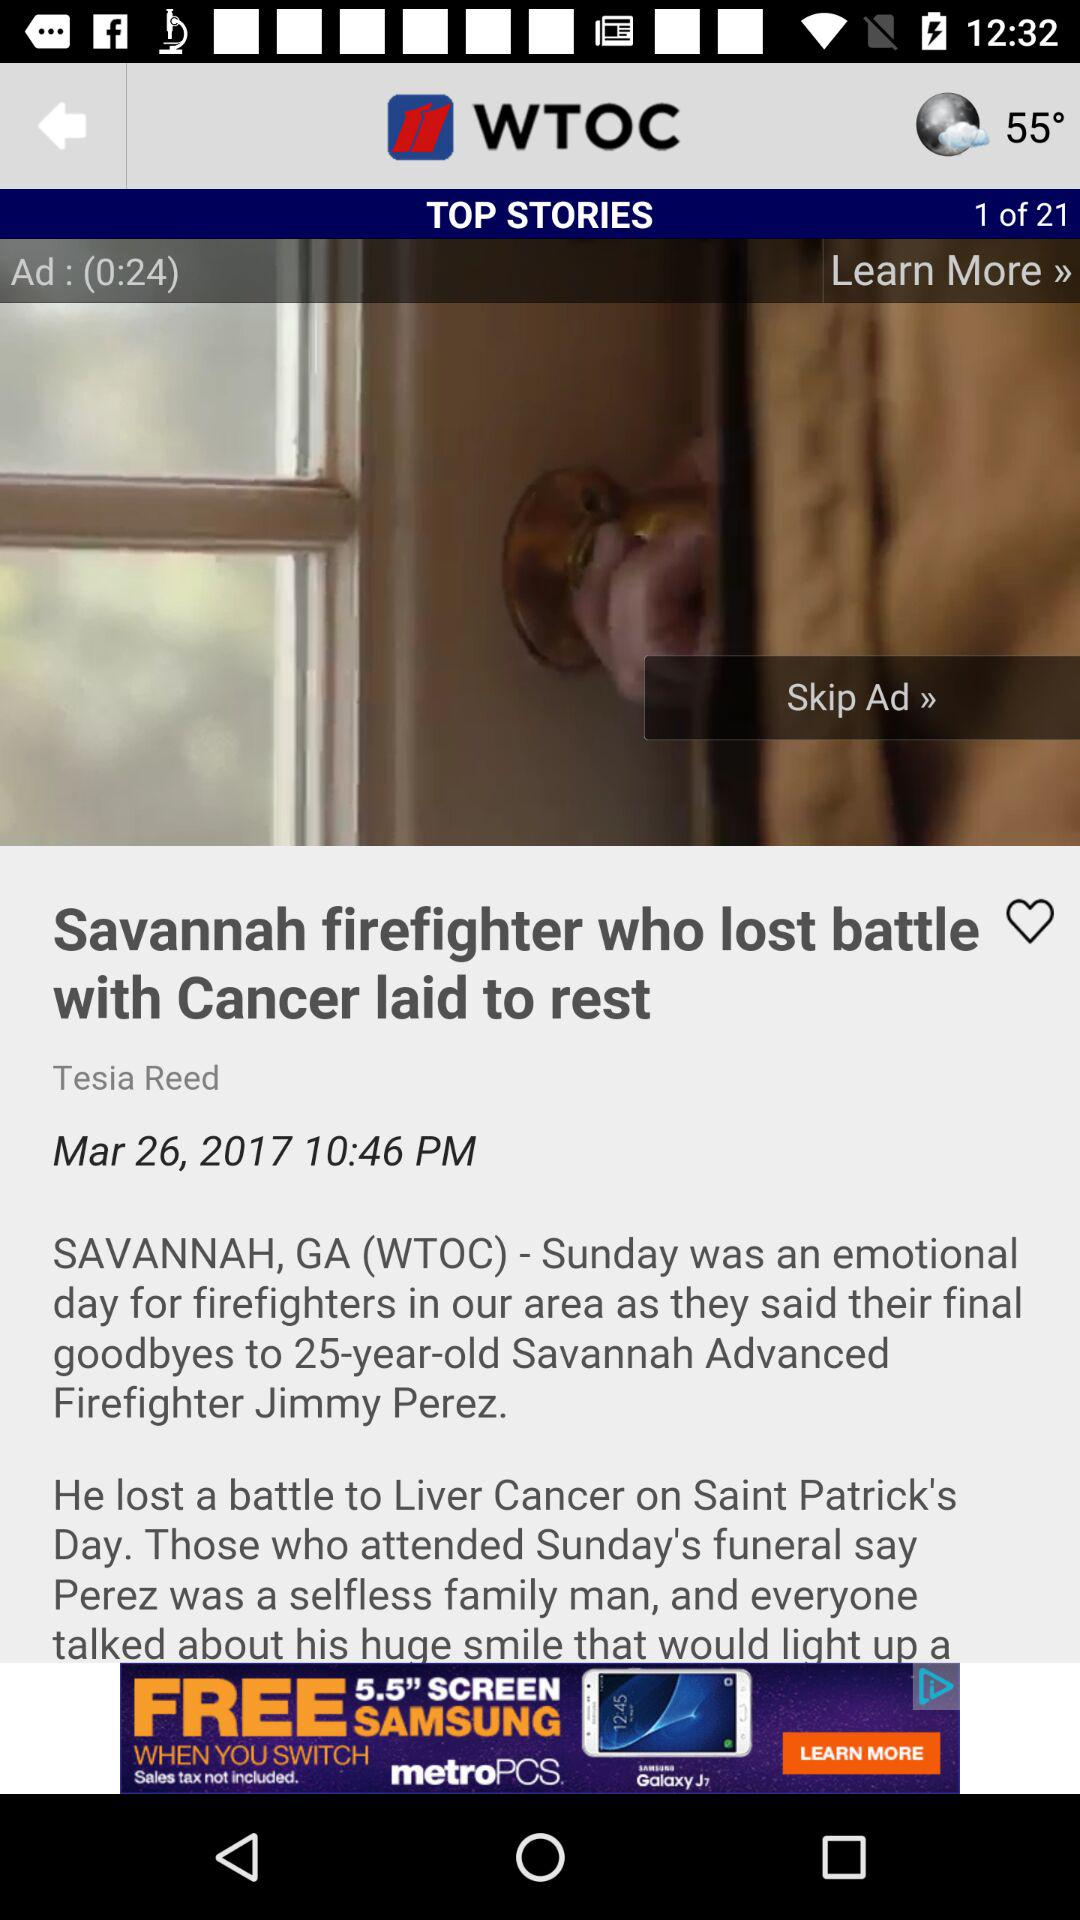What is the shown temperature? The shown temperature is 55°. 